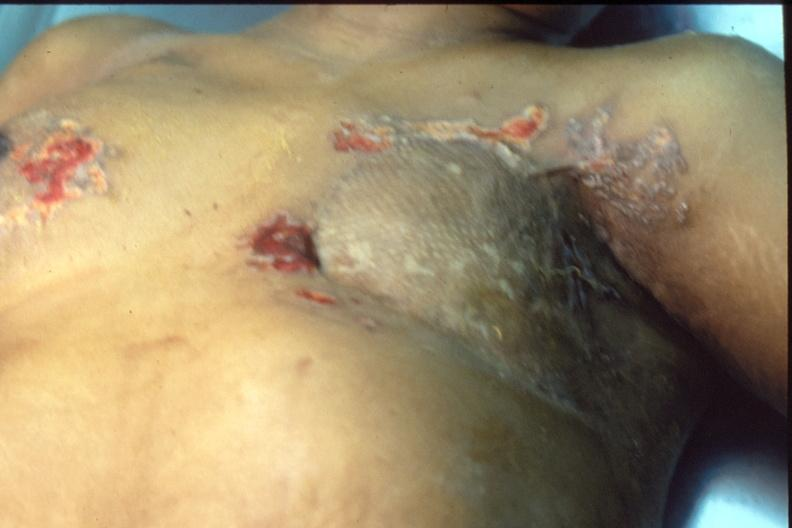what does this image show?
Answer the question using a single word or phrase. Mastectomy scars with skin metastases 